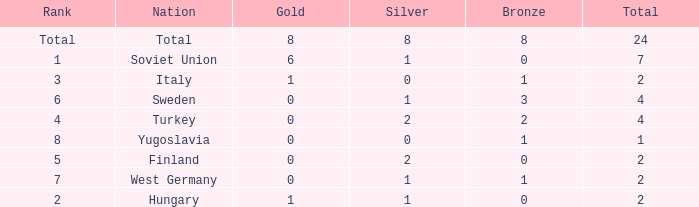What is the highest Total, when Gold is 1, when Nation is Hungary, and when Bronze is less than 0? None. 